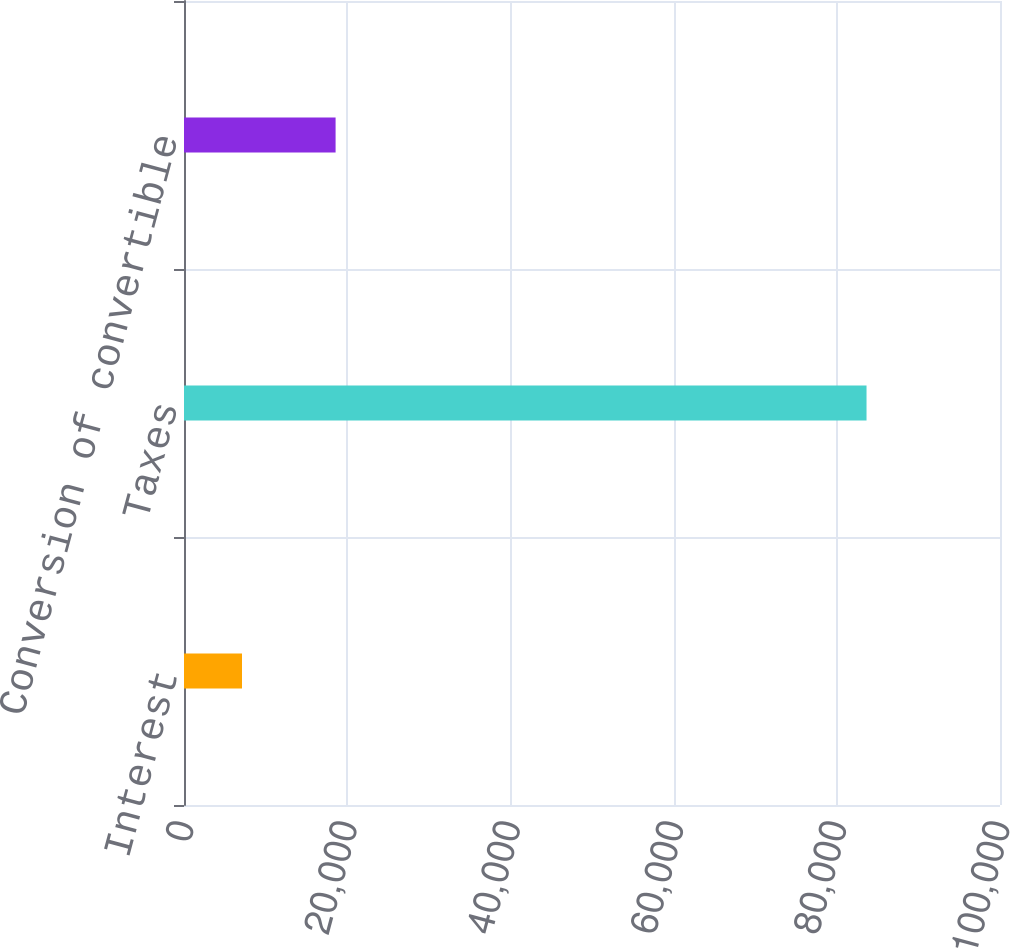<chart> <loc_0><loc_0><loc_500><loc_500><bar_chart><fcel>Interest<fcel>Taxes<fcel>Conversion of convertible<nl><fcel>7108<fcel>83644<fcel>18577<nl></chart> 